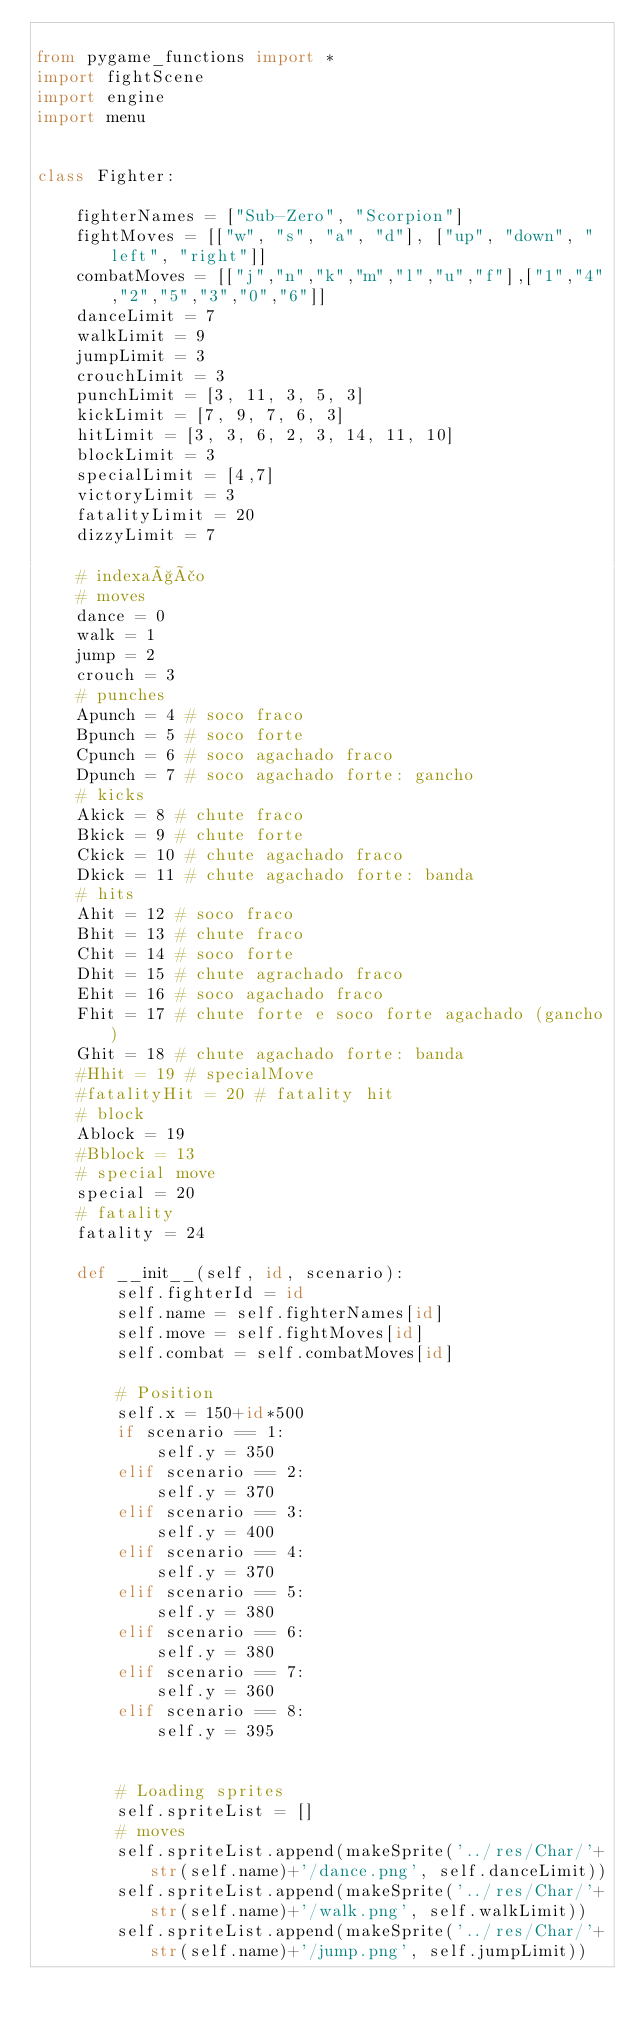Convert code to text. <code><loc_0><loc_0><loc_500><loc_500><_Python_>
from pygame_functions import *
import fightScene
import engine
import menu


class Fighter:

    fighterNames = ["Sub-Zero", "Scorpion"]
    fightMoves = [["w", "s", "a", "d"], ["up", "down", "left", "right"]]
    combatMoves = [["j","n","k","m","l","u","f"],["1","4","2","5","3","0","6"]]
    danceLimit = 7
    walkLimit = 9
    jumpLimit = 3
    crouchLimit = 3
    punchLimit = [3, 11, 3, 5, 3]
    kickLimit = [7, 9, 7, 6, 3]
    hitLimit = [3, 3, 6, 2, 3, 14, 11, 10]
    blockLimit = 3
    specialLimit = [4,7]
    victoryLimit = 3
    fatalityLimit = 20
    dizzyLimit = 7

    # indexação
    # moves
    dance = 0
    walk = 1
    jump = 2
    crouch = 3
    # punches
    Apunch = 4 # soco fraco
    Bpunch = 5 # soco forte
    Cpunch = 6 # soco agachado fraco
    Dpunch = 7 # soco agachado forte: gancho
    # kicks
    Akick = 8 # chute fraco
    Bkick = 9 # chute forte
    Ckick = 10 # chute agachado fraco
    Dkick = 11 # chute agachado forte: banda
    # hits
    Ahit = 12 # soco fraco
    Bhit = 13 # chute fraco
    Chit = 14 # soco forte
    Dhit = 15 # chute agrachado fraco
    Ehit = 16 # soco agachado fraco
    Fhit = 17 # chute forte e soco forte agachado (gancho)
    Ghit = 18 # chute agachado forte: banda
    #Hhit = 19 # specialMove
    #fatalityHit = 20 # fatality hit
    # block
    Ablock = 19
    #Bblock = 13
    # special move
    special = 20
    # fatality
    fatality = 24 

    def __init__(self, id, scenario):
        self.fighterId = id
        self.name = self.fighterNames[id]
        self.move = self.fightMoves[id]
        self.combat = self.combatMoves[id] 

        # Position
        self.x = 150+id*500
        if scenario == 1:
            self.y = 350
        elif scenario == 2:
            self.y = 370
        elif scenario == 3:
            self.y = 400
        elif scenario == 4:
            self.y = 370
        elif scenario == 5:
            self.y = 380
        elif scenario == 6:
            self.y = 380
        elif scenario == 7:
            self.y = 360
        elif scenario == 8:
            self.y = 395          


        # Loading sprites
        self.spriteList = []
        # moves
        self.spriteList.append(makeSprite('../res/Char/'+str(self.name)+'/dance.png', self.danceLimit)) 
        self.spriteList.append(makeSprite('../res/Char/'+str(self.name)+'/walk.png', self.walkLimit))
        self.spriteList.append(makeSprite('../res/Char/'+str(self.name)+'/jump.png', self.jumpLimit))</code> 